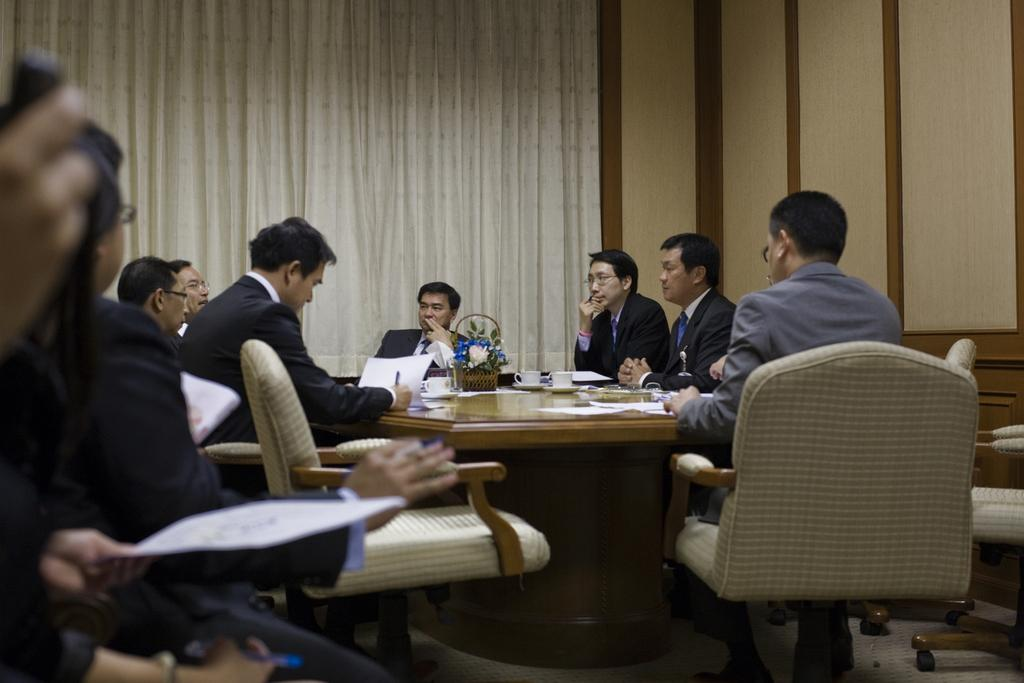What are the people in the image doing? The people in the image are sitting on chairs. What is on the table in the image? There are cups and papers on the table. What can be seen in the background of the image? There is a curtain and a wall in the background of the image. What type of quince is being used as a decoration on the table? There is no quince present on the table in the image. What is the color of the blood on the people's mouths in the image? There is no blood or mouths visible in the image; it only shows people sitting on chairs, a table, cups, papers, a curtain, and a wall. 